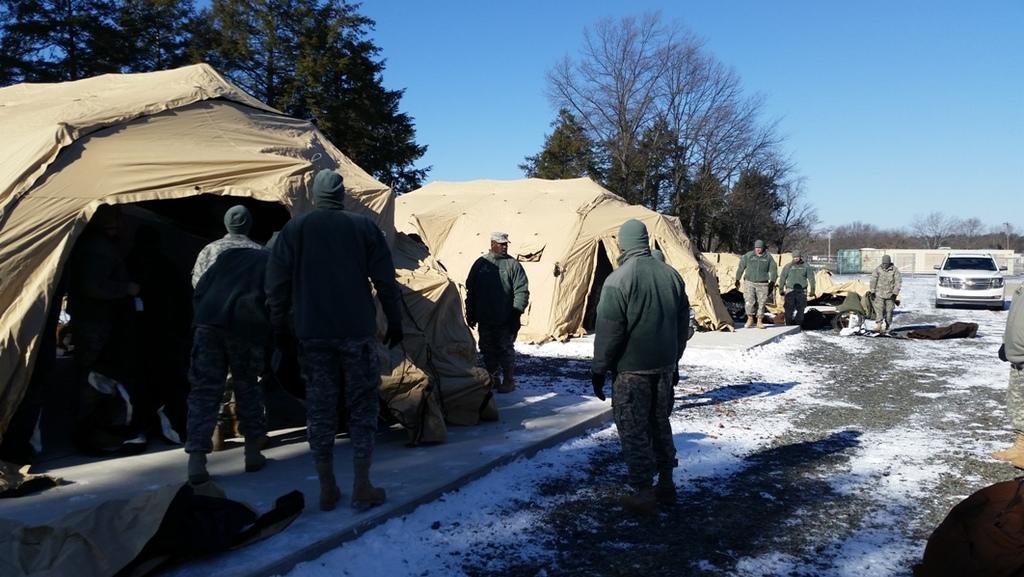Please provide a concise description of this image. In this image we can see a sky. There are few tents in the image. There are many people in the image. There is a snow in the image. There are many trees in the image. There is a vehicle in the image. There are many objects placed on the ground. 